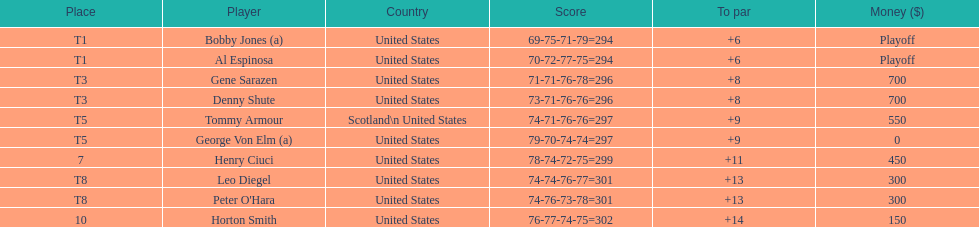What was al espinosa's total stroke count at the final of the 1929 us open? 294. 